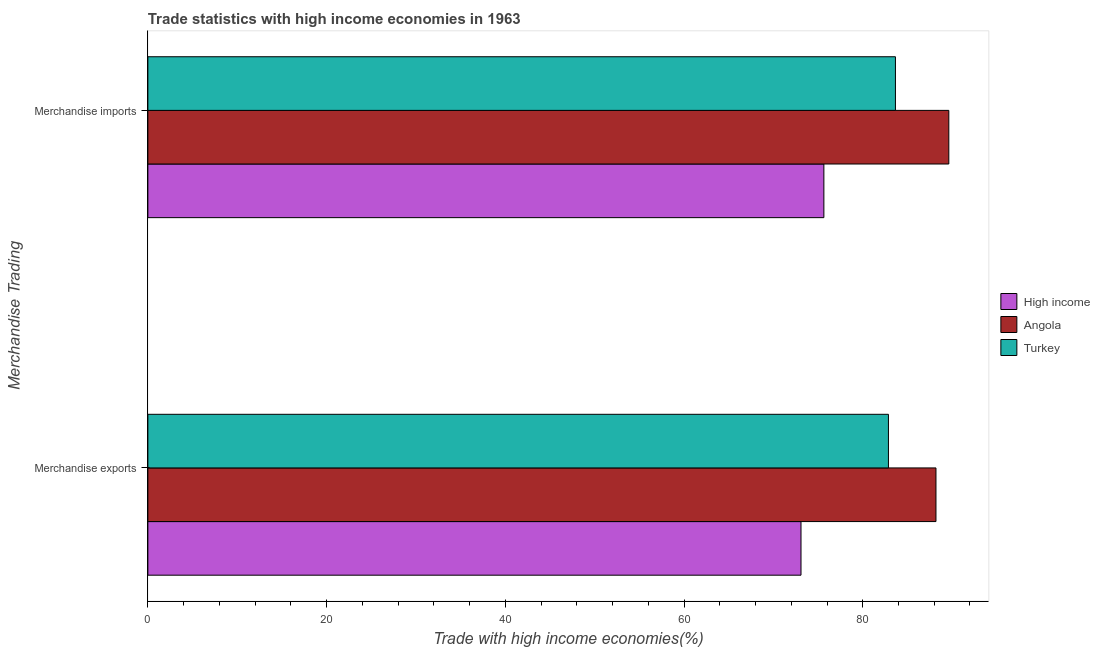How many different coloured bars are there?
Provide a short and direct response. 3. How many groups of bars are there?
Ensure brevity in your answer.  2. Are the number of bars on each tick of the Y-axis equal?
Make the answer very short. Yes. How many bars are there on the 2nd tick from the bottom?
Your answer should be compact. 3. What is the merchandise exports in Angola?
Ensure brevity in your answer.  88.2. Across all countries, what is the maximum merchandise exports?
Offer a very short reply. 88.2. Across all countries, what is the minimum merchandise imports?
Your answer should be very brief. 75.65. In which country was the merchandise exports maximum?
Keep it short and to the point. Angola. What is the total merchandise exports in the graph?
Offer a terse response. 244.16. What is the difference between the merchandise exports in Turkey and that in Angola?
Keep it short and to the point. -5.32. What is the difference between the merchandise imports in Angola and the merchandise exports in Turkey?
Your answer should be compact. 6.76. What is the average merchandise imports per country?
Your answer should be very brief. 82.98. What is the difference between the merchandise exports and merchandise imports in Turkey?
Offer a terse response. -0.78. What is the ratio of the merchandise exports in Turkey to that in High income?
Provide a short and direct response. 1.13. In how many countries, is the merchandise exports greater than the average merchandise exports taken over all countries?
Give a very brief answer. 2. What does the 3rd bar from the top in Merchandise imports represents?
Make the answer very short. High income. Are all the bars in the graph horizontal?
Make the answer very short. Yes. Does the graph contain any zero values?
Make the answer very short. No. Does the graph contain grids?
Ensure brevity in your answer.  No. Where does the legend appear in the graph?
Offer a terse response. Center right. What is the title of the graph?
Your answer should be very brief. Trade statistics with high income economies in 1963. Does "Qatar" appear as one of the legend labels in the graph?
Offer a very short reply. No. What is the label or title of the X-axis?
Your response must be concise. Trade with high income economies(%). What is the label or title of the Y-axis?
Provide a succinct answer. Merchandise Trading. What is the Trade with high income economies(%) of High income in Merchandise exports?
Your answer should be compact. 73.09. What is the Trade with high income economies(%) of Angola in Merchandise exports?
Offer a very short reply. 88.2. What is the Trade with high income economies(%) of Turkey in Merchandise exports?
Provide a succinct answer. 82.88. What is the Trade with high income economies(%) in High income in Merchandise imports?
Your response must be concise. 75.65. What is the Trade with high income economies(%) of Angola in Merchandise imports?
Give a very brief answer. 89.63. What is the Trade with high income economies(%) in Turkey in Merchandise imports?
Offer a very short reply. 83.66. Across all Merchandise Trading, what is the maximum Trade with high income economies(%) of High income?
Your answer should be very brief. 75.65. Across all Merchandise Trading, what is the maximum Trade with high income economies(%) in Angola?
Offer a very short reply. 89.63. Across all Merchandise Trading, what is the maximum Trade with high income economies(%) of Turkey?
Ensure brevity in your answer.  83.66. Across all Merchandise Trading, what is the minimum Trade with high income economies(%) in High income?
Make the answer very short. 73.09. Across all Merchandise Trading, what is the minimum Trade with high income economies(%) of Angola?
Offer a terse response. 88.2. Across all Merchandise Trading, what is the minimum Trade with high income economies(%) of Turkey?
Your response must be concise. 82.88. What is the total Trade with high income economies(%) of High income in the graph?
Make the answer very short. 148.74. What is the total Trade with high income economies(%) in Angola in the graph?
Offer a terse response. 177.83. What is the total Trade with high income economies(%) of Turkey in the graph?
Your response must be concise. 166.54. What is the difference between the Trade with high income economies(%) of High income in Merchandise exports and that in Merchandise imports?
Keep it short and to the point. -2.56. What is the difference between the Trade with high income economies(%) in Angola in Merchandise exports and that in Merchandise imports?
Ensure brevity in your answer.  -1.44. What is the difference between the Trade with high income economies(%) in Turkey in Merchandise exports and that in Merchandise imports?
Offer a terse response. -0.78. What is the difference between the Trade with high income economies(%) in High income in Merchandise exports and the Trade with high income economies(%) in Angola in Merchandise imports?
Provide a short and direct response. -16.54. What is the difference between the Trade with high income economies(%) in High income in Merchandise exports and the Trade with high income economies(%) in Turkey in Merchandise imports?
Make the answer very short. -10.57. What is the difference between the Trade with high income economies(%) in Angola in Merchandise exports and the Trade with high income economies(%) in Turkey in Merchandise imports?
Provide a short and direct response. 4.54. What is the average Trade with high income economies(%) in High income per Merchandise Trading?
Your answer should be compact. 74.37. What is the average Trade with high income economies(%) in Angola per Merchandise Trading?
Offer a very short reply. 88.91. What is the average Trade with high income economies(%) in Turkey per Merchandise Trading?
Offer a terse response. 83.27. What is the difference between the Trade with high income economies(%) in High income and Trade with high income economies(%) in Angola in Merchandise exports?
Provide a succinct answer. -15.1. What is the difference between the Trade with high income economies(%) in High income and Trade with high income economies(%) in Turkey in Merchandise exports?
Give a very brief answer. -9.78. What is the difference between the Trade with high income economies(%) in Angola and Trade with high income economies(%) in Turkey in Merchandise exports?
Make the answer very short. 5.32. What is the difference between the Trade with high income economies(%) of High income and Trade with high income economies(%) of Angola in Merchandise imports?
Provide a short and direct response. -13.98. What is the difference between the Trade with high income economies(%) of High income and Trade with high income economies(%) of Turkey in Merchandise imports?
Keep it short and to the point. -8.01. What is the difference between the Trade with high income economies(%) of Angola and Trade with high income economies(%) of Turkey in Merchandise imports?
Give a very brief answer. 5.97. What is the ratio of the Trade with high income economies(%) of High income in Merchandise exports to that in Merchandise imports?
Provide a short and direct response. 0.97. What is the ratio of the Trade with high income economies(%) of Angola in Merchandise exports to that in Merchandise imports?
Provide a short and direct response. 0.98. What is the ratio of the Trade with high income economies(%) of Turkey in Merchandise exports to that in Merchandise imports?
Offer a terse response. 0.99. What is the difference between the highest and the second highest Trade with high income economies(%) of High income?
Keep it short and to the point. 2.56. What is the difference between the highest and the second highest Trade with high income economies(%) of Angola?
Make the answer very short. 1.44. What is the difference between the highest and the second highest Trade with high income economies(%) in Turkey?
Give a very brief answer. 0.78. What is the difference between the highest and the lowest Trade with high income economies(%) of High income?
Your answer should be very brief. 2.56. What is the difference between the highest and the lowest Trade with high income economies(%) in Angola?
Keep it short and to the point. 1.44. What is the difference between the highest and the lowest Trade with high income economies(%) in Turkey?
Ensure brevity in your answer.  0.78. 